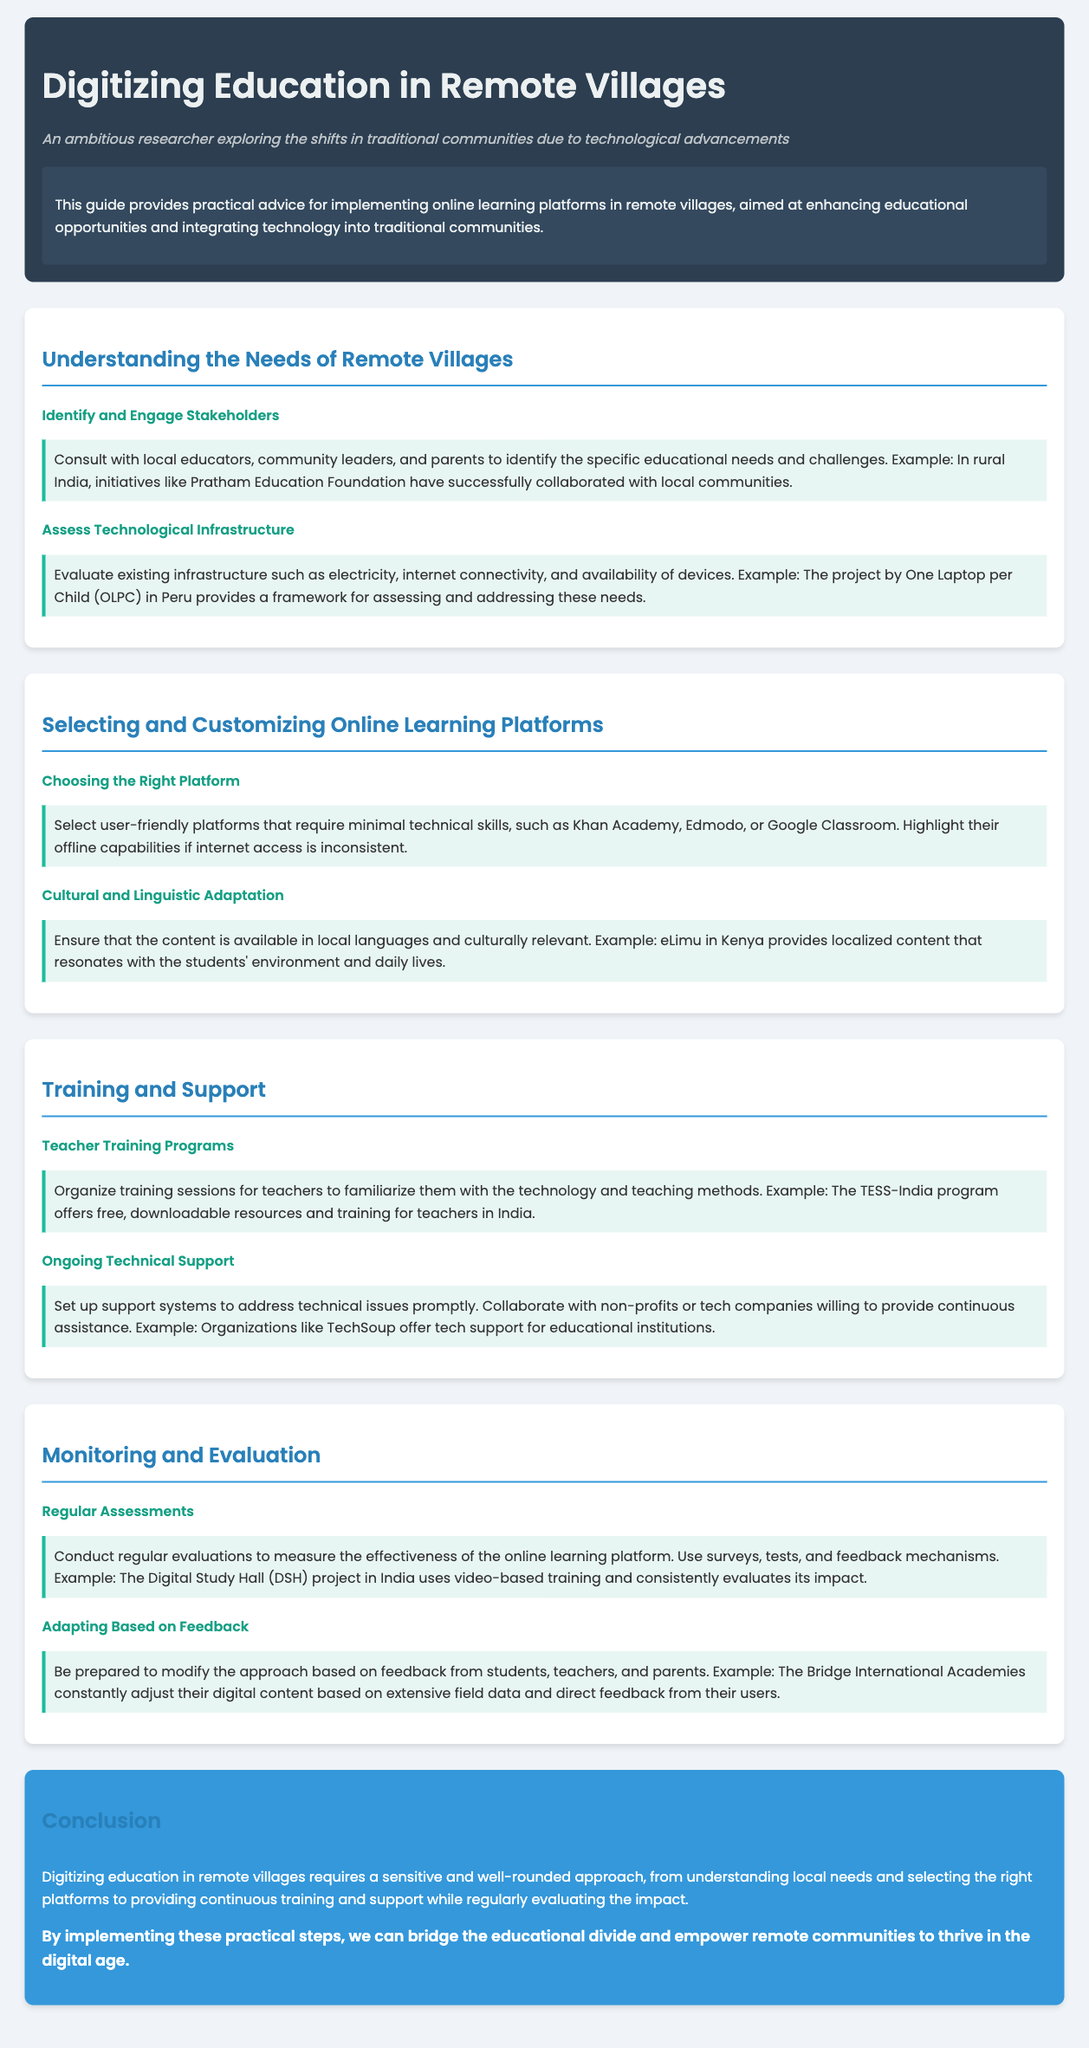What is the title of the guide? The title of the guide is mentioned in the header section.
Answer: Digitizing Education in Remote Villages Who should be consulted to identify educational needs? The document states that local educators, community leaders, and parents should be consulted.
Answer: Local educators, community leaders, and parents What example is given for assessing technological infrastructure? The document mentions an example related to a specific project addressing technology in Peru.
Answer: One Laptop per Child (OLPC) Which online learning platform is highlighted for its offline capabilities? The guide refers to specific platforms, including those that can function without internet access.
Answer: Khan Academy What is the focus of the TESS-India program? The guide describes this program's goal regarding teacher training sessions.
Answer: Free training for teachers How often should evaluations be conducted according to the guide? The guide emphasizes the need for regular assessments to measure effectiveness.
Answer: Regularly What example is used for adapting based on feedback? The document provides a specific example of an organization adjusting their content based on feedback.
Answer: Bridge International Academies What is the essential approach for digitizing education according to the conclusion? The conclusion describes the overall approach needed for effective education digitization.
Answer: Sensitive and well-rounded approach 